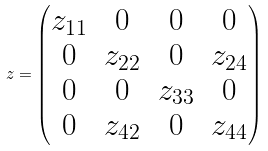<formula> <loc_0><loc_0><loc_500><loc_500>z = \begin{pmatrix} z _ { 1 1 } & 0 & 0 & 0 \\ 0 & z _ { 2 2 } & 0 & z _ { 2 4 } \\ 0 & 0 & z _ { 3 3 } & 0 \\ 0 & z _ { 4 2 } & 0 & z _ { 4 4 } \end{pmatrix}</formula> 